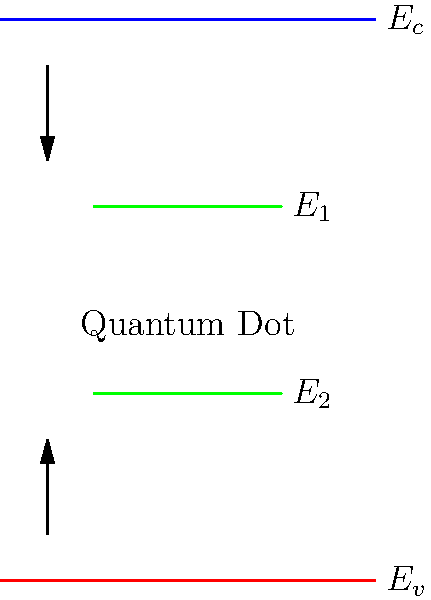In the energy band diagram of a quantum dot shown above, what is the primary reason for the appearance of discrete energy levels $E_1$ and $E_2$ between the conduction band $E_c$ and valence band $E_v$? To understand the appearance of discrete energy levels in a quantum dot, we need to consider the following steps:

1. Quantum confinement: In a quantum dot, charge carriers (electrons and holes) are confined in all three spatial dimensions, typically to a region of a few nanometers.

2. De Broglie wavelength: The confinement dimensions are comparable to the de Broglie wavelength of the charge carriers, which is given by $\lambda = h/p$, where $h$ is Planck's constant and $p$ is the momentum.

3. Quantization of energy levels: Due to this confinement, the energy states of the charge carriers become quantized, similar to the "particle in a box" problem in quantum mechanics.

4. Discrete energy levels: Instead of continuous energy bands as in bulk semiconductors, quantum dots exhibit discrete energy levels (E₁ and E₂ in the diagram) within the bandgap.

5. Size dependence: The energy spacing between these discrete levels is inversely proportional to the size of the quantum dot. Smaller dots have larger energy level spacing.

6. Tunable properties: This size-dependent energy quantization allows for tuning of optical and electronic properties of quantum dots, making them valuable for various nanotechnology applications.

The discrete energy levels E₁ and E₂ in the diagram represent the allowed energy states for electrons and holes, respectively, resulting from this quantum confinement effect.
Answer: Quantum confinement 